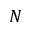Convert formula to latex. <formula><loc_0><loc_0><loc_500><loc_500>N</formula> 